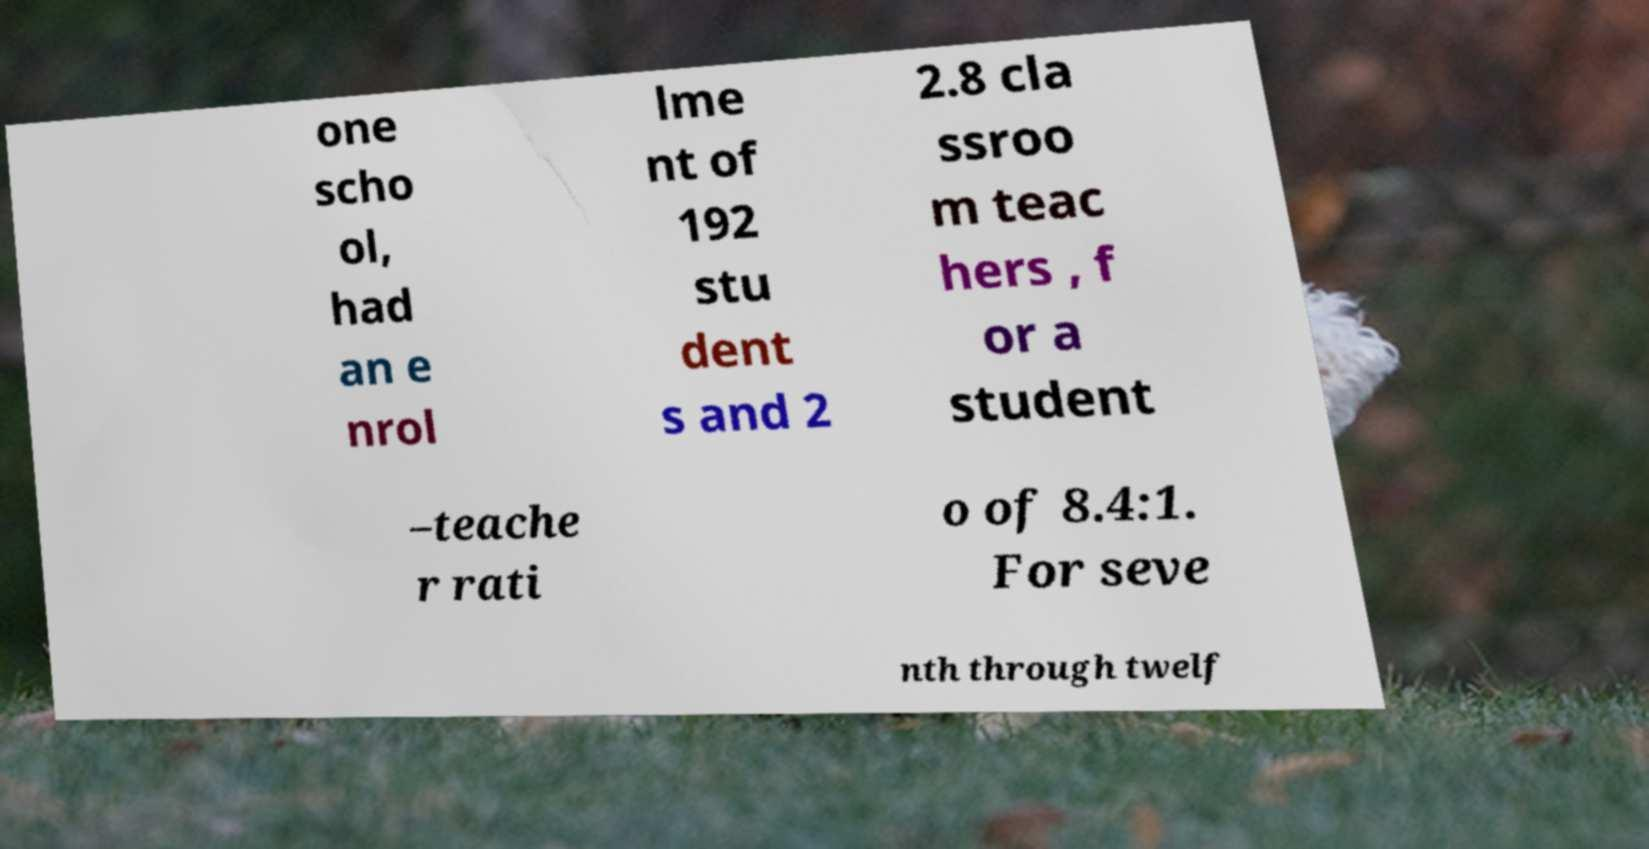Please read and relay the text visible in this image. What does it say? one scho ol, had an e nrol lme nt of 192 stu dent s and 2 2.8 cla ssroo m teac hers , f or a student –teache r rati o of 8.4:1. For seve nth through twelf 